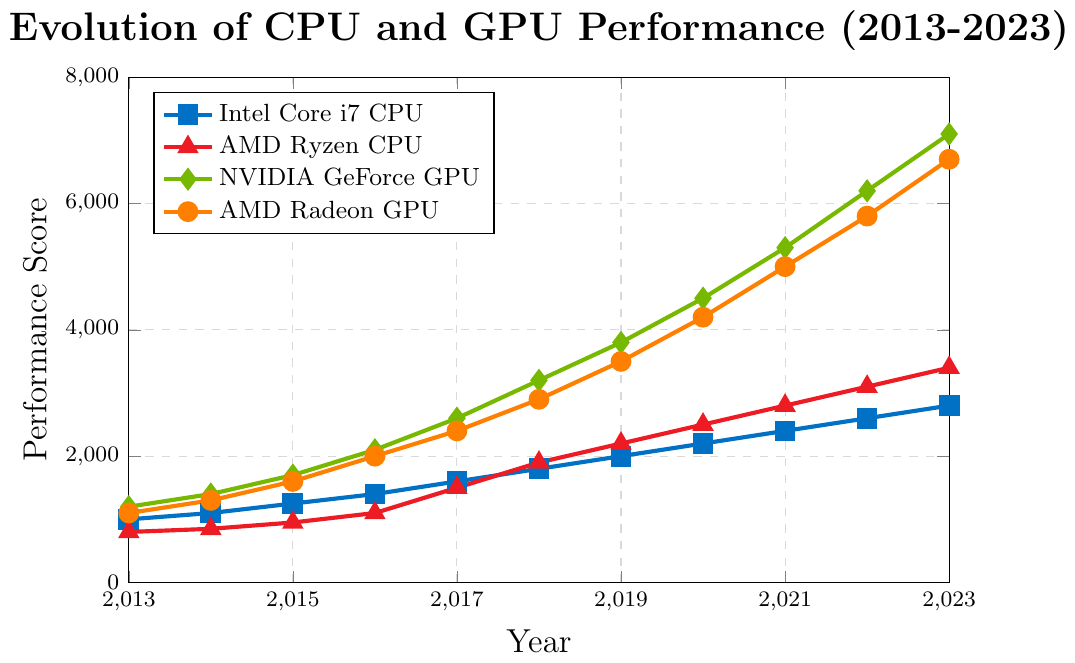What’s the difference in performance score between Intel Core i7 and AMD Ryzen CPUs in 2023? To find the difference, subtract the AMD Ryzen score from the Intel Core i7 score for 2023: 2800 - 3400 = -600.
Answer: -600 Which GPU had a higher performance score in 2018, NVIDIA GeForce or AMD Radeon? Compare the performance scores of both GPUs in 2018. NVIDIA GeForce: 3200, AMD Radeon: 2900.
Answer: NVIDIA GeForce In which year did AMD Ryzen CPUs first surpass a performance score of 2000? Look at the scores for AMD Ryzen CPUs each year. The score first surpasses 2000 in 2019 with a score of 2200.
Answer: 2019 What is the total increase in performance score for NVIDIA GeForce GPUs from 2013 to 2023? Subtract the 2013 score from the 2023 score for NVIDIA GeForce: 7100 - 1200 = 5900.
Answer: 5900 Which CPU had a higher growth rate in performance score between 2016 and 2017, Intel Core i7 or AMD Ryzen? Calculate the growth for each CPU between 2016 and 2017. Intel Core i7: 1600-1400 = 200, AMD Ryzen: 1500-1100 = 400.
Answer: AMD Ryzen Between which two consecutive years did Intel Core i7 CPUs see the largest increase in performance score? Find the differences for each consecutive year and identify the largest increase. 2013-2014: 100, 2014-2015: 150, 2015-2016: 150, 2016-2017: 200, 2017-2018: 200, 2018-2019: 200, 2019-2020: 200, 2020-2021: 200, 2021-2022: 200, 2022-2023: 200. Largest increase is 200 and occurs multiple times but first between 2016-2017.
Answer: 2016-2017 What is the average performance score of AMD Radeon GPUs over the decade shown? Sum the AMD Radeon GPU scores from 2013 to 2023 and divide by the number of years: (1100 + 1300 + 1600 + 2000 + 2400 + 2900 + 3500 + 4200 + 5000 + 5800 + 6700) / 11 = 3118.18 (rounded to two decimal places).
Answer: 3118.18 How does the performance score of AMD Radeon GPUs in 2023 compare to their score in 2013? Compare the performance scores for AMD Radeon GPUs in 2023 and 2013: 6700 (2023) > 1100 (2013), indicating a considerable increase.
Answer: Increased Which year saw Intel Core i7 CPUs reach double the performance score of AMD Ryzen CPUs from 2013? Identify when Intel Core i7 score was double the AMD Ryzen 2013 score. AMD Ryzen 2013 score: 800, double that is 1600. Intel Core i7 reached 1600 in 2017.
Answer: 2017 What is the combined performance score of both GPUs in 2020? Add the scores of NVIDIA GeForce and AMD Radeon GPUs for 2020: 4500 + 4200 = 8700.
Answer: 8700 